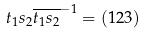<formula> <loc_0><loc_0><loc_500><loc_500>t _ { 1 } s _ { 2 } \overline { t _ { 1 } s _ { 2 } } ^ { - 1 } = ( 1 2 3 )</formula> 